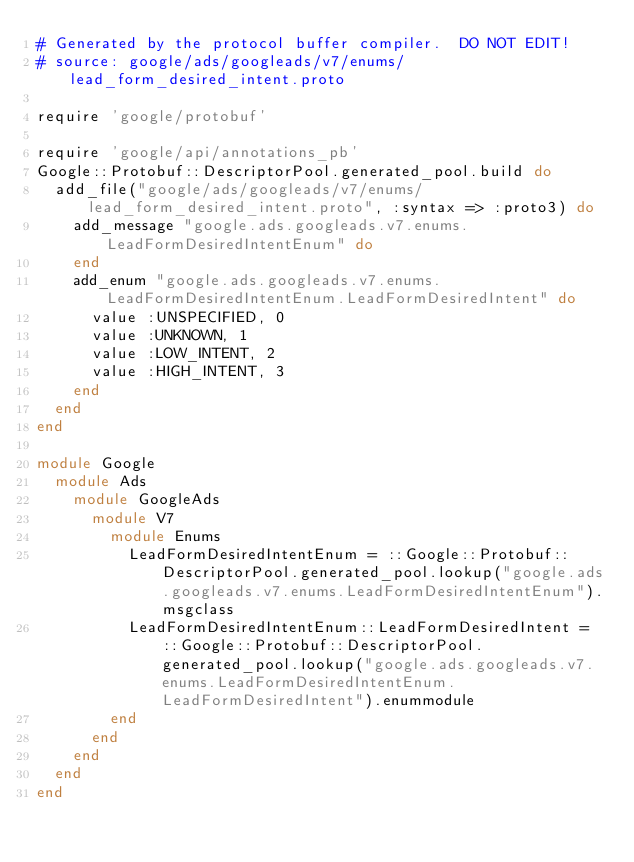Convert code to text. <code><loc_0><loc_0><loc_500><loc_500><_Ruby_># Generated by the protocol buffer compiler.  DO NOT EDIT!
# source: google/ads/googleads/v7/enums/lead_form_desired_intent.proto

require 'google/protobuf'

require 'google/api/annotations_pb'
Google::Protobuf::DescriptorPool.generated_pool.build do
  add_file("google/ads/googleads/v7/enums/lead_form_desired_intent.proto", :syntax => :proto3) do
    add_message "google.ads.googleads.v7.enums.LeadFormDesiredIntentEnum" do
    end
    add_enum "google.ads.googleads.v7.enums.LeadFormDesiredIntentEnum.LeadFormDesiredIntent" do
      value :UNSPECIFIED, 0
      value :UNKNOWN, 1
      value :LOW_INTENT, 2
      value :HIGH_INTENT, 3
    end
  end
end

module Google
  module Ads
    module GoogleAds
      module V7
        module Enums
          LeadFormDesiredIntentEnum = ::Google::Protobuf::DescriptorPool.generated_pool.lookup("google.ads.googleads.v7.enums.LeadFormDesiredIntentEnum").msgclass
          LeadFormDesiredIntentEnum::LeadFormDesiredIntent = ::Google::Protobuf::DescriptorPool.generated_pool.lookup("google.ads.googleads.v7.enums.LeadFormDesiredIntentEnum.LeadFormDesiredIntent").enummodule
        end
      end
    end
  end
end
</code> 